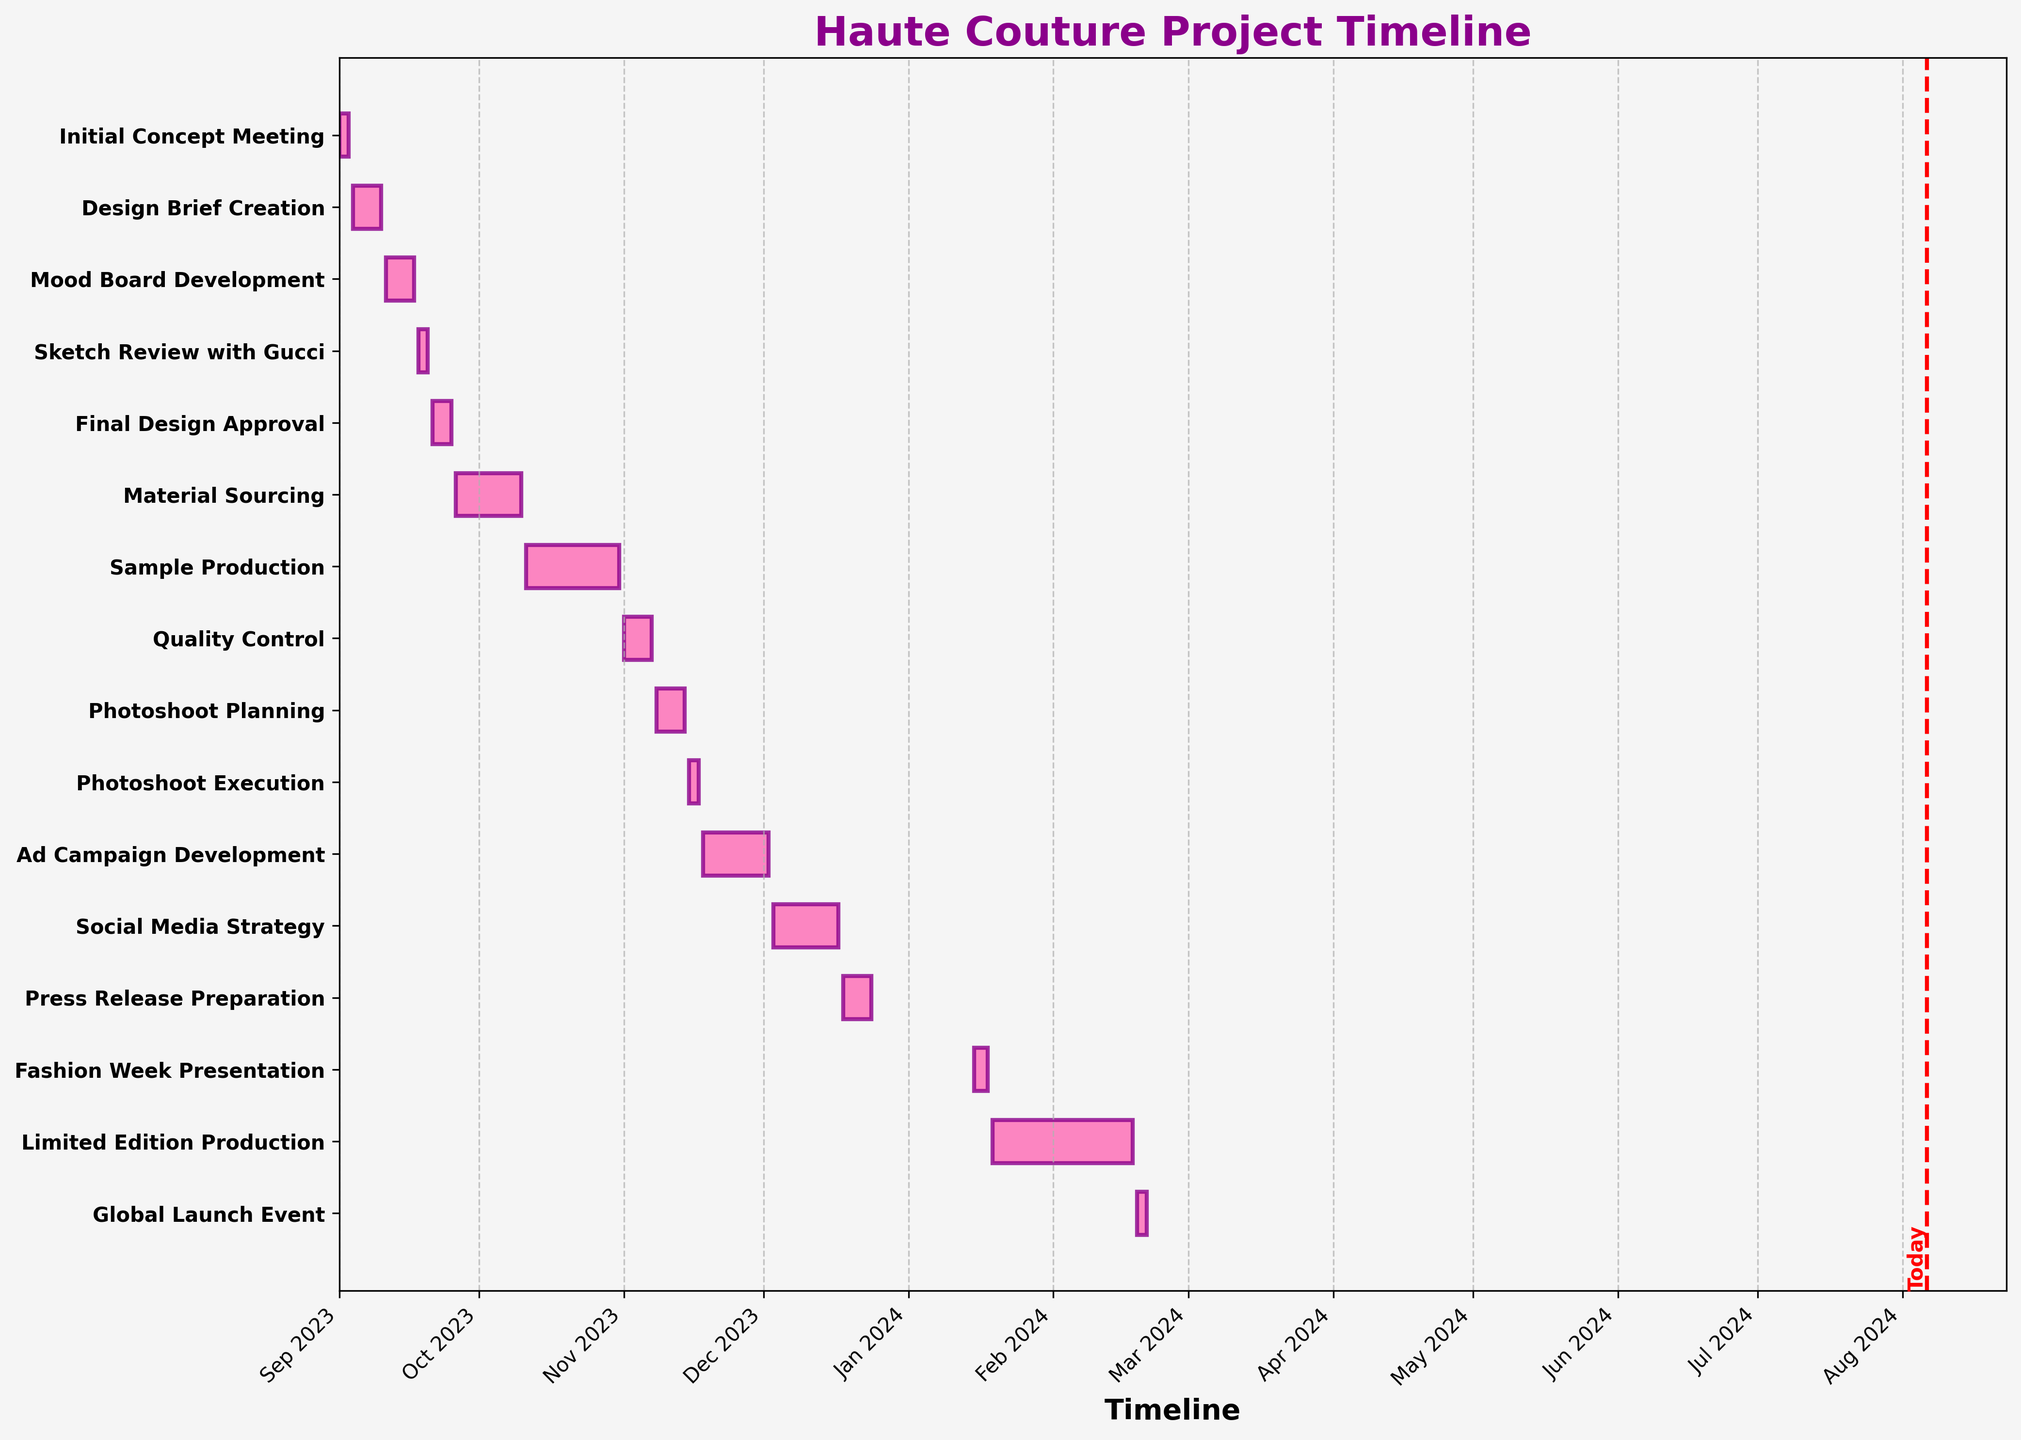what’s the title of the figure? The title is found at the top of the Gantt chart and is typically formatted in a larger and bold font. The title is clearly visible and states the overall purpose of the chart.
Answer: Haute Couture Project Timeline What task starts immediately after the "Initial Concept Meeting"? By looking at the sequence of tasks along the y-axis and the corresponding start dates, the task immediately following "Initial Concept Meeting" can be identified.
Answer: Design Brief Creation What is the duration of the "Sample Production" phase? The duration of the "Sample Production" phase is indicated directly in the dataset under the "Duration" column next to the task name.
Answer: 21 days Which task ends right before the "Fashion Week Presentation"? By examining the timeline of tasks on the Gantt chart and identifying the task that finishes on, or very close to, 01-14-2024 (the date just before the start of Fashion Week Presentation), the preceding task can be determined.
Answer: Press Release Preparation How many days are spent in the "Mood Board Development" phase? The duration for "Mood Board Development" is explicitly mentioned in the "Duration" column in the dataset next to the task name.
Answer: 7 days Which task has the longest duration? The task with the longest duration can be identified by comparing the bar lengths across all tasks or referring to the "Duration" column in the dataset.
Answer: Limited Edition Production How much longer is the "Material Sourcing" phase compared to "Photoshoot Execution"? By checking the durations of these two tasks in the dataset: Material Sourcing is 15 days and Photoshoot Execution is 3 days. Subtracting these values gives the difference.
Answer: 12 days longer When does the "Global Launch Event" take place relative to "Quality Control"? By examining the timeline dates for both tasks and noting their positions on the Gantt chart, the Global Launch Event is held some time after the Quality Control phase.
Answer: After What is the overall duration of the project from start to finish? Calculate the overall timeline by subtracting the start date of the first task from the end date of the last task. It starts on 09-01-2023 and ends on 02-21-2024.
Answer: Approximately 5.5 months What is the color used to represent the tasks in this Gantt chart? The color used for the task bars in the Gantt chart can be seen visually and appears as a specific shade.
Answer: Pink 